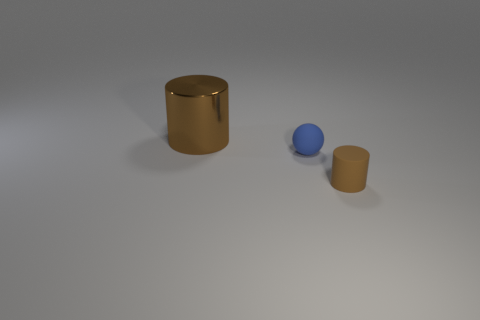Add 1 large yellow matte cylinders. How many objects exist? 4 Subtract all balls. How many objects are left? 2 Subtract all large cylinders. Subtract all red metallic things. How many objects are left? 2 Add 1 tiny blue balls. How many tiny blue balls are left? 2 Add 3 tiny rubber cylinders. How many tiny rubber cylinders exist? 4 Subtract 1 blue spheres. How many objects are left? 2 